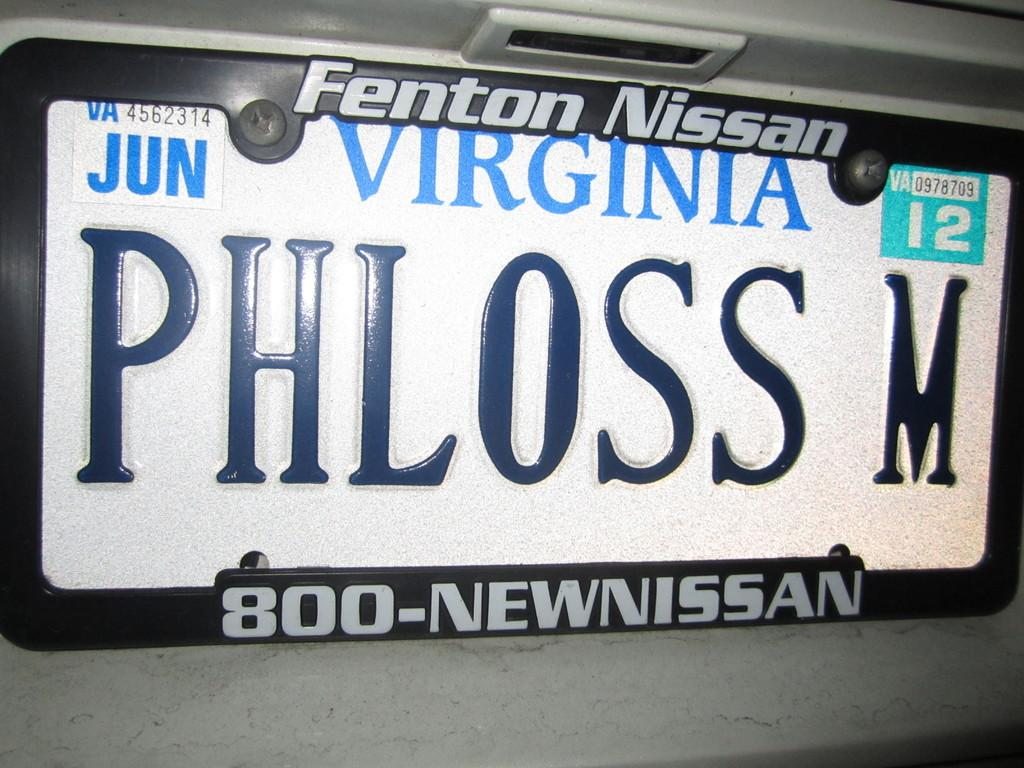<image>
Provide a brief description of the given image. A Virginia licence plate on which the number 12 is visible. 